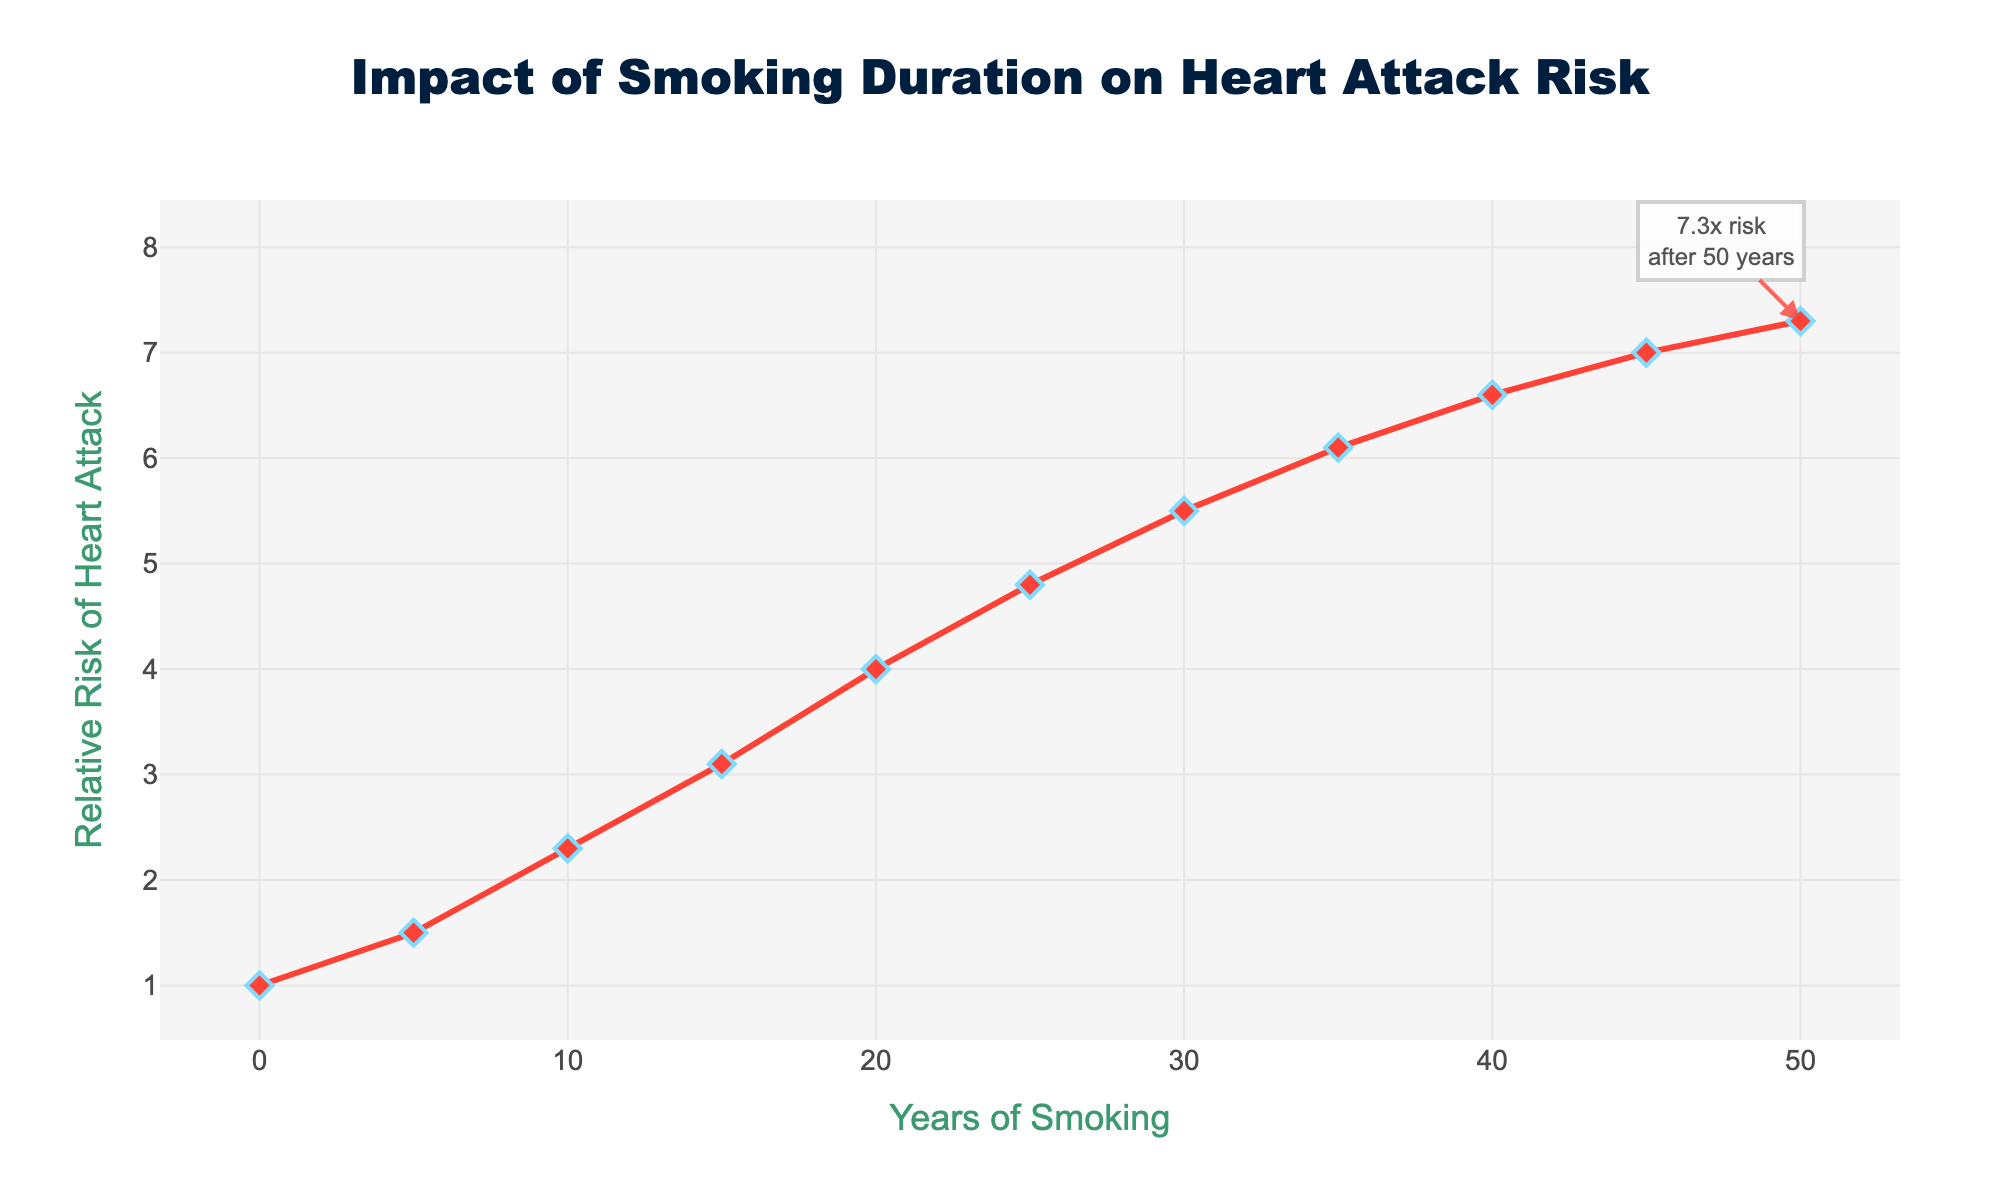What is the relative risk of heart attack after 20 years of smoking? Find the point on the x-axis that corresponds to 20 years and trace it up to the line, then read the y-axis value at that point. The relative risk is 4.0 after 20 years of smoking.
Answer: 4.0 How much does the risk of heart attack increase between smoking for 5 years and 15 years? Find the y-axis values for 5 years (1.5) and 15 years (3.1), then subtract the relative risk at 5 years from the relative risk at 15 years (3.1 - 1.5). The increase in risk is 1.6.
Answer: 1.6 After how many years of smoking does the relative risk of heart attack exceed 5? Locate the y-axis value of 5 on the chart, then trace it horizontally to the line and down to the x-axis to determine the corresponding number of years. The relative risk exceeds 5 after approximately 30 years of smoking.
Answer: 30 years What is the general trend of the relative risk of heart attack as the years of smoking increase? Observe the slope of the line throughout the chart. The line consistently slopes upward, indicating that the relative risk of a heart attack increases as the years of smoking increase.
Answer: Increases By how much does the relative risk of heart attack change from 0 years to 50 years of smoking? Find the relative risk values for 0 years (1.0) and 50 years (7.3), then calculate the difference (7.3 - 1.0). The change in relative risk is 6.3.
Answer: 6.3 Which year shows the highest relative risk of heart attack, and what is that risk? Identify the highest point on the y-axis and trace it to the corresponding year on the x-axis. The highest relative risk (7.3) occurs at 50 years.
Answer: 50 years, 7.3 What is the difference in relative risk between smoking for 10 years and 35 years? Find the y-axis values for 10 years (2.3) and 35 years (6.1), then calculate the difference (6.1 - 2.3). The difference in relative risk is 3.8.
Answer: 3.8 Which color is used to represent the line showing the relative risk of heart attack? Observe the color of the line in the chart. The line is represented with a red color.
Answer: Red 